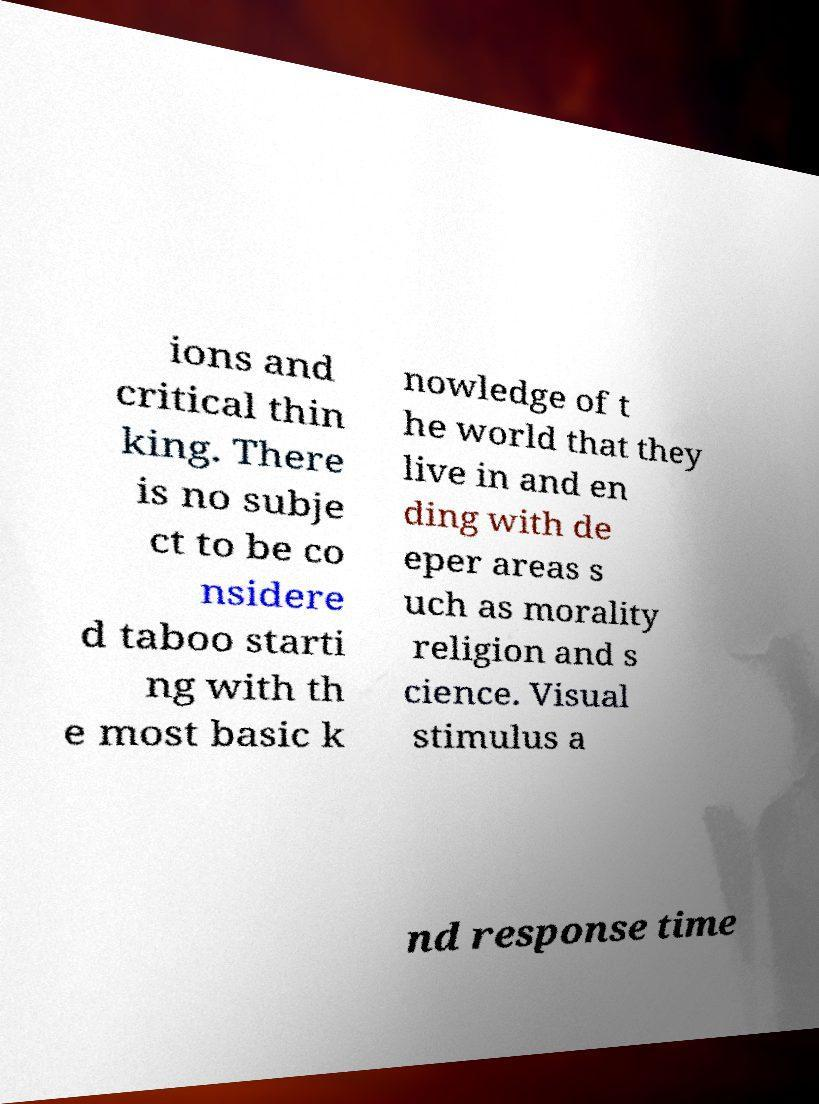I need the written content from this picture converted into text. Can you do that? ions and critical thin king. There is no subje ct to be co nsidere d taboo starti ng with th e most basic k nowledge of t he world that they live in and en ding with de eper areas s uch as morality religion and s cience. Visual stimulus a nd response time 